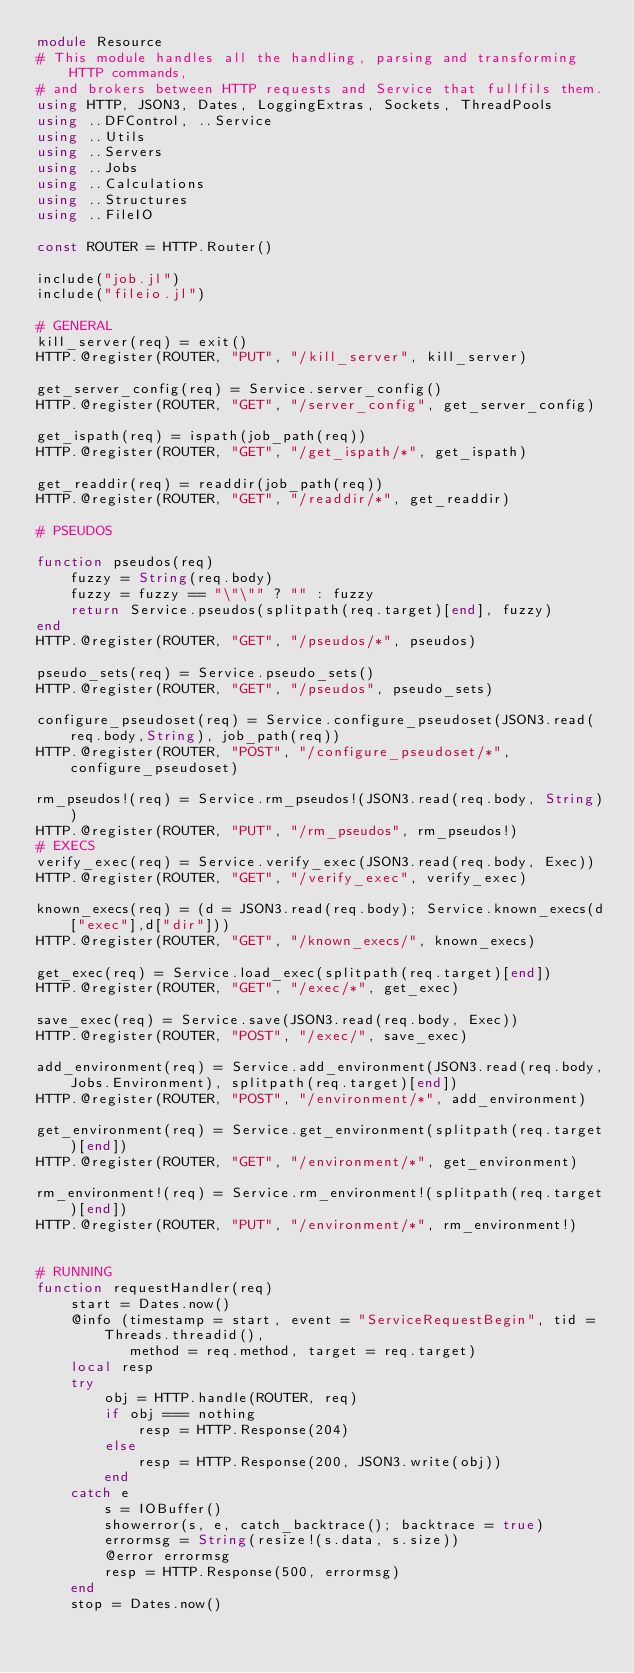Convert code to text. <code><loc_0><loc_0><loc_500><loc_500><_Julia_>module Resource
# This module handles all the handling, parsing and transforming HTTP commands,
# and brokers between HTTP requests and Service that fullfils them. 
using HTTP, JSON3, Dates, LoggingExtras, Sockets, ThreadPools
using ..DFControl, ..Service
using ..Utils
using ..Servers
using ..Jobs
using ..Calculations
using ..Structures
using ..FileIO

const ROUTER = HTTP.Router()

include("job.jl")
include("fileio.jl")

# GENERAL
kill_server(req) = exit()
HTTP.@register(ROUTER, "PUT", "/kill_server", kill_server)

get_server_config(req) = Service.server_config()
HTTP.@register(ROUTER, "GET", "/server_config", get_server_config)

get_ispath(req) = ispath(job_path(req))
HTTP.@register(ROUTER, "GET", "/get_ispath/*", get_ispath)

get_readdir(req) = readdir(job_path(req))
HTTP.@register(ROUTER, "GET", "/readdir/*", get_readdir)

# PSEUDOS

function pseudos(req)
    fuzzy = String(req.body)
    fuzzy = fuzzy == "\"\"" ? "" : fuzzy
    return Service.pseudos(splitpath(req.target)[end], fuzzy)
end
HTTP.@register(ROUTER, "GET", "/pseudos/*", pseudos)

pseudo_sets(req) = Service.pseudo_sets()
HTTP.@register(ROUTER, "GET", "/pseudos", pseudo_sets)

configure_pseudoset(req) = Service.configure_pseudoset(JSON3.read(req.body,String), job_path(req))
HTTP.@register(ROUTER, "POST", "/configure_pseudoset/*", configure_pseudoset)

rm_pseudos!(req) = Service.rm_pseudos!(JSON3.read(req.body, String))
HTTP.@register(ROUTER, "PUT", "/rm_pseudos", rm_pseudos!)
# EXECS
verify_exec(req) = Service.verify_exec(JSON3.read(req.body, Exec))
HTTP.@register(ROUTER, "GET", "/verify_exec", verify_exec)

known_execs(req) = (d = JSON3.read(req.body); Service.known_execs(d["exec"],d["dir"]))
HTTP.@register(ROUTER, "GET", "/known_execs/", known_execs)

get_exec(req) = Service.load_exec(splitpath(req.target)[end])
HTTP.@register(ROUTER, "GET", "/exec/*", get_exec)

save_exec(req) = Service.save(JSON3.read(req.body, Exec))
HTTP.@register(ROUTER, "POST", "/exec/", save_exec)

add_environment(req) = Service.add_environment(JSON3.read(req.body,Jobs.Environment), splitpath(req.target)[end])
HTTP.@register(ROUTER, "POST", "/environment/*", add_environment)

get_environment(req) = Service.get_environment(splitpath(req.target)[end])
HTTP.@register(ROUTER, "GET", "/environment/*", get_environment)

rm_environment!(req) = Service.rm_environment!(splitpath(req.target)[end])
HTTP.@register(ROUTER, "PUT", "/environment/*", rm_environment!)


# RUNNING
function requestHandler(req)
    start = Dates.now()
    @info (timestamp = start, event = "ServiceRequestBegin", tid = Threads.threadid(),
           method = req.method, target = req.target)
    local resp
    try
        obj = HTTP.handle(ROUTER, req)
        if obj === nothing
            resp = HTTP.Response(204)
        else
            resp = HTTP.Response(200, JSON3.write(obj))
        end
    catch e
        s = IOBuffer()
        showerror(s, e, catch_backtrace(); backtrace = true)
        errormsg = String(resize!(s.data, s.size))
        @error errormsg
        resp = HTTP.Response(500, errormsg)
    end
    stop = Dates.now()</code> 